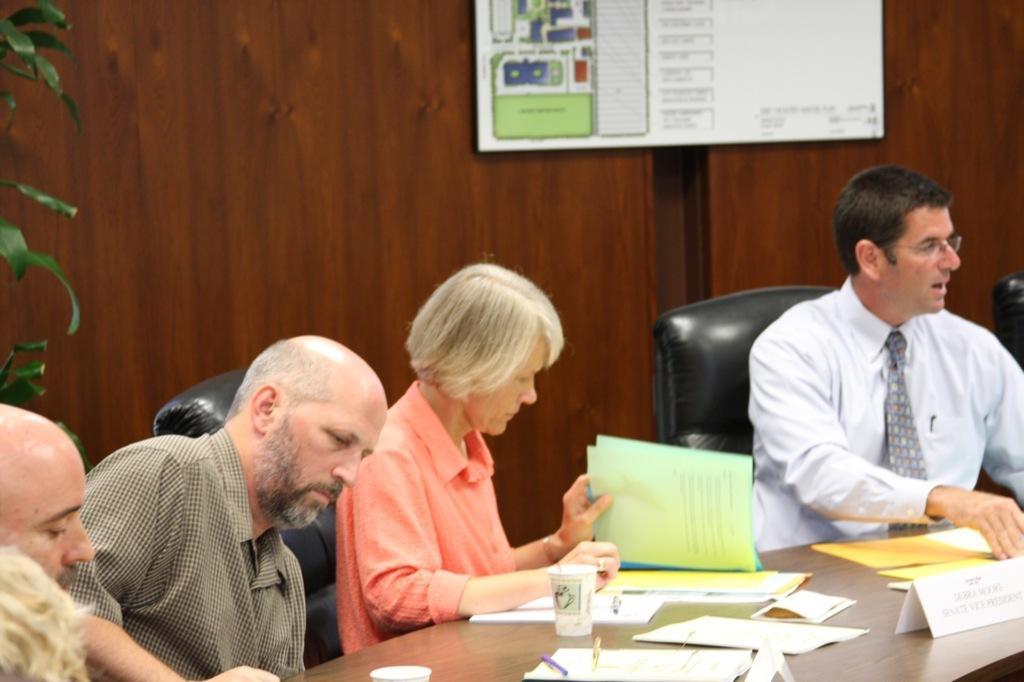In one or two sentences, can you explain what this image depicts? There is a room. They are sitting in a chair. There is a table. There is a paper,pen ,cup and name board on a table. On the right side we have a white color shirt person. He's wearing a tie. 